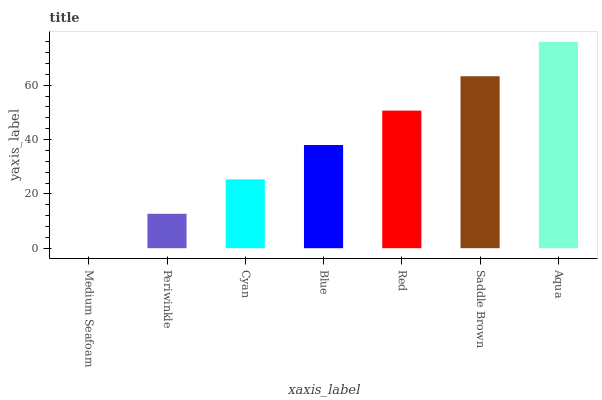Is Medium Seafoam the minimum?
Answer yes or no. Yes. Is Aqua the maximum?
Answer yes or no. Yes. Is Periwinkle the minimum?
Answer yes or no. No. Is Periwinkle the maximum?
Answer yes or no. No. Is Periwinkle greater than Medium Seafoam?
Answer yes or no. Yes. Is Medium Seafoam less than Periwinkle?
Answer yes or no. Yes. Is Medium Seafoam greater than Periwinkle?
Answer yes or no. No. Is Periwinkle less than Medium Seafoam?
Answer yes or no. No. Is Blue the high median?
Answer yes or no. Yes. Is Blue the low median?
Answer yes or no. Yes. Is Aqua the high median?
Answer yes or no. No. Is Red the low median?
Answer yes or no. No. 